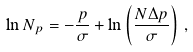Convert formula to latex. <formula><loc_0><loc_0><loc_500><loc_500>\ln N _ { p } = - \frac { p } { \sigma } + \ln \left ( \frac { N \Delta p } { \sigma } \right ) \, ,</formula> 